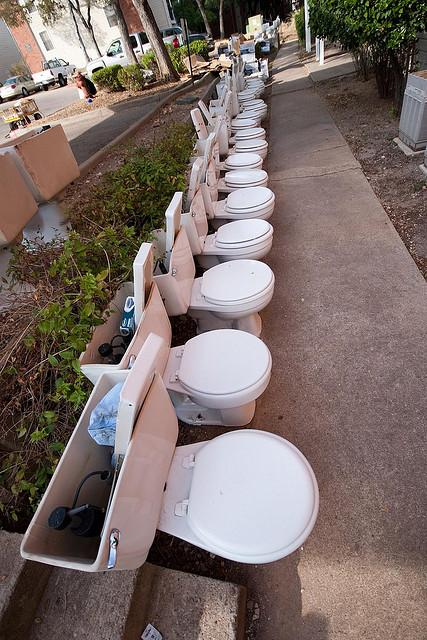What's happening with these toilets?

Choices:
A) discarding them
B) cleaning them
C) selling them
D) displaying them displaying them 